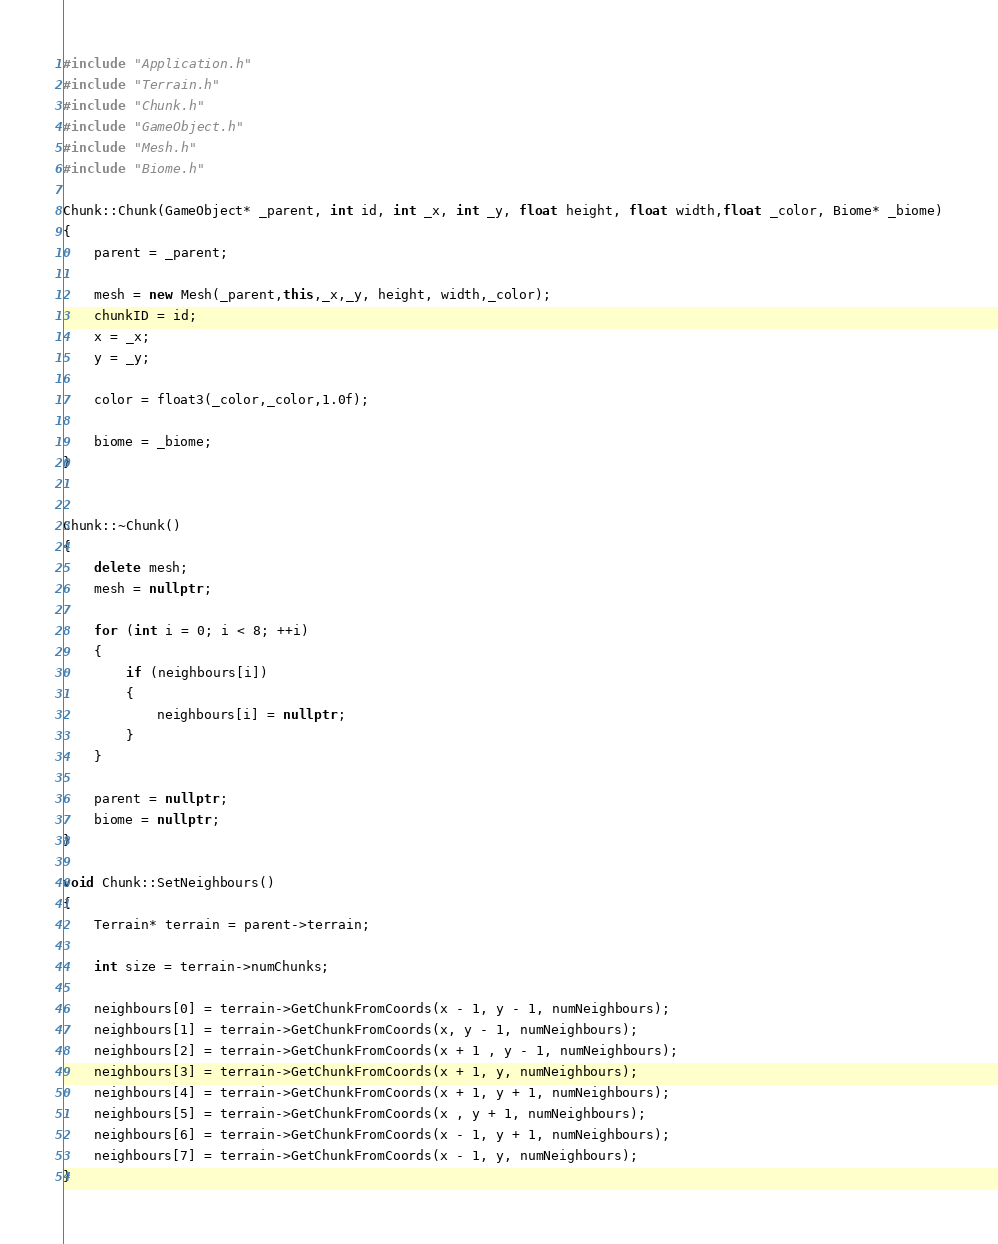<code> <loc_0><loc_0><loc_500><loc_500><_C++_>#include "Application.h"
#include "Terrain.h"
#include "Chunk.h"
#include "GameObject.h"
#include "Mesh.h"
#include "Biome.h"

Chunk::Chunk(GameObject* _parent, int id, int _x, int _y, float height, float width,float _color, Biome* _biome)
{
	parent = _parent;

	mesh = new Mesh(_parent,this,_x,_y, height, width,_color);
	chunkID = id;
	x = _x;
	y = _y;

	color = float3(_color,_color,1.0f);

	biome = _biome;
}


Chunk::~Chunk()
{
	delete mesh;
	mesh = nullptr;

	for (int i = 0; i < 8; ++i)
	{
		if (neighbours[i])
		{
			neighbours[i] = nullptr;
		}
	}

	parent = nullptr;
	biome = nullptr;
}

void Chunk::SetNeighbours()
{
	Terrain* terrain = parent->terrain;

	int size = terrain->numChunks;

	neighbours[0] = terrain->GetChunkFromCoords(x - 1, y - 1, numNeighbours);
	neighbours[1] = terrain->GetChunkFromCoords(x, y - 1, numNeighbours);
	neighbours[2] = terrain->GetChunkFromCoords(x + 1 , y - 1, numNeighbours);
	neighbours[3] = terrain->GetChunkFromCoords(x + 1, y, numNeighbours);
	neighbours[4] = terrain->GetChunkFromCoords(x + 1, y + 1, numNeighbours);
	neighbours[5] = terrain->GetChunkFromCoords(x , y + 1, numNeighbours);
	neighbours[6] = terrain->GetChunkFromCoords(x - 1, y + 1, numNeighbours);
	neighbours[7] = terrain->GetChunkFromCoords(x - 1, y, numNeighbours);
}

</code> 